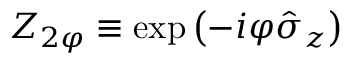Convert formula to latex. <formula><loc_0><loc_0><loc_500><loc_500>Z _ { 2 \varphi } \equiv \exp \left ( - i \varphi \hat { \sigma } _ { z } \right )</formula> 